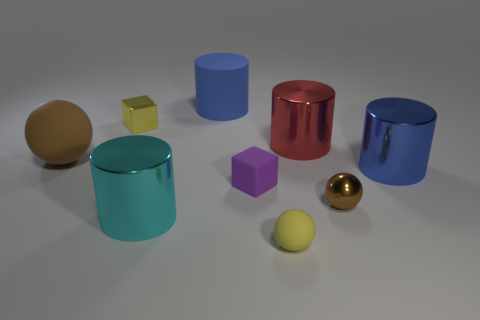Subtract 1 cylinders. How many cylinders are left? 3 Subtract all balls. How many objects are left? 6 Add 8 blue metallic objects. How many blue metallic objects are left? 9 Add 1 small yellow blocks. How many small yellow blocks exist? 2 Subtract 0 cyan spheres. How many objects are left? 9 Subtract all big red metal cylinders. Subtract all blue objects. How many objects are left? 6 